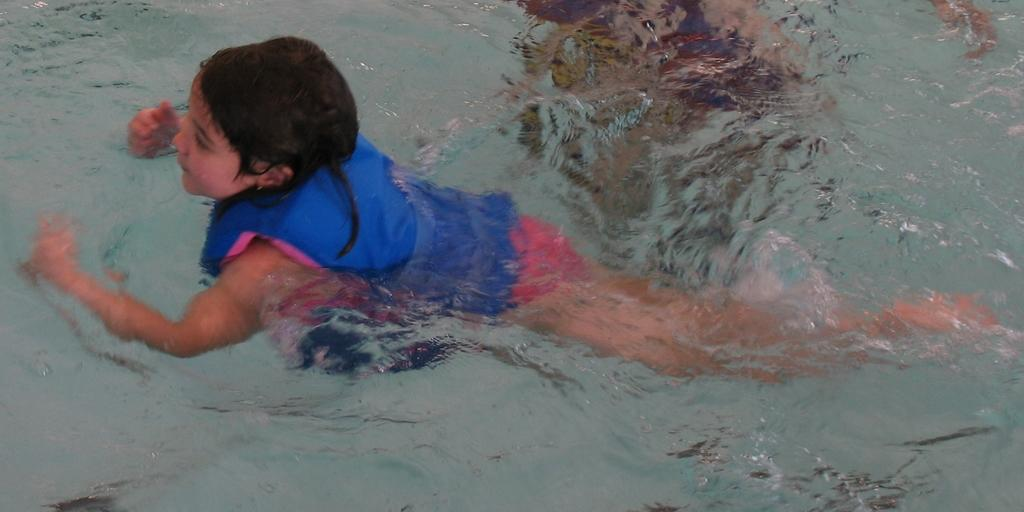What is the person in the image doing? The person is swimming in a pool in the image. What is the pool filled with? The pool is filled with water. What color is the jacket the person is wearing? The person is wearing a blue jacket. What type of body is present in the image? There is no body present in the image, only a person swimming in a pool. What sort of quarter is visible in the image? There is no reference to a quarter in the image. 